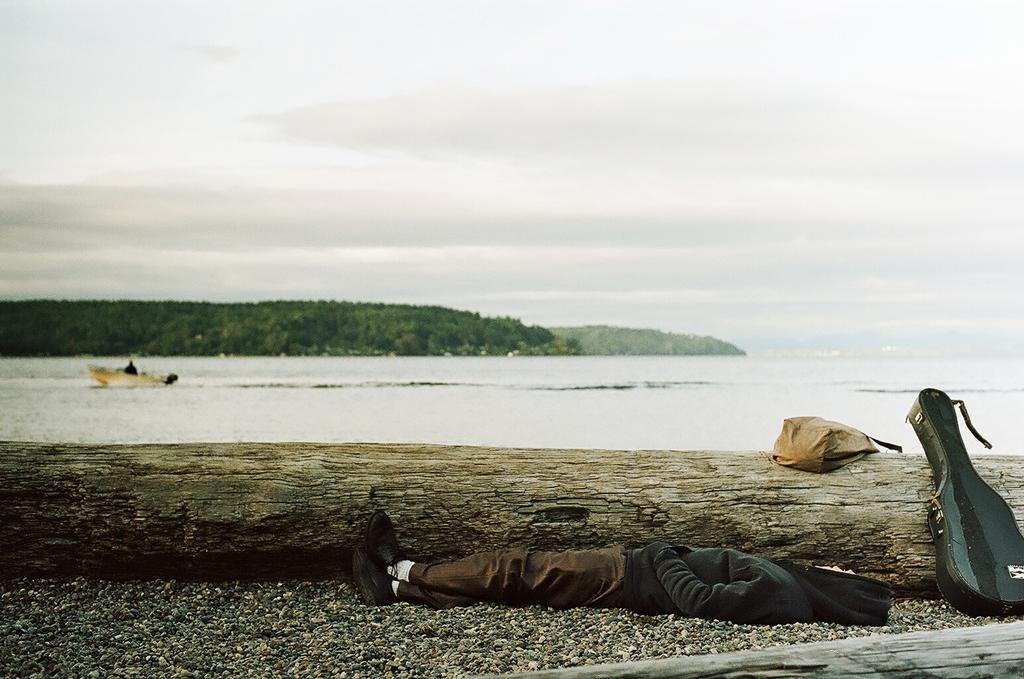Describe this image in one or two sentences. This picture is clicked outside. In the foreground we can see a person lying on the ground and we can see the gravel, guitar and a bag is placed on an object which seems to be the trunk of a tree. In the bottom right corner we can see a wooden object. In the background we can see the sky, trees like objects and we can see a person seems to be rowing a boat in the water body. 